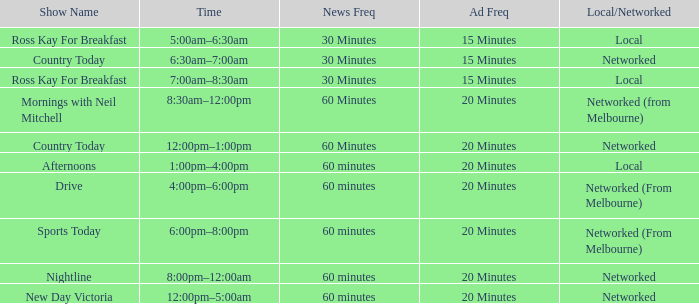What Time has Ad Freq of 15 minutes, and a Show Name of country today? 6:30am–7:00am. 